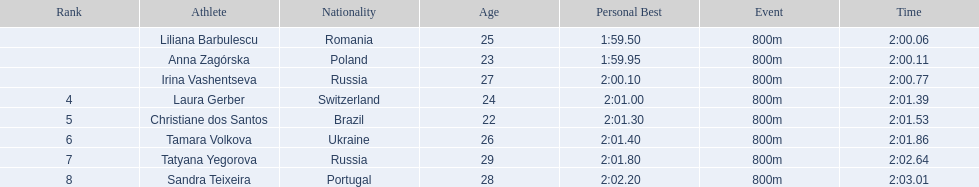What athletes are in the top five for the women's 800 metres? Liliana Barbulescu, Anna Zagórska, Irina Vashentseva, Laura Gerber, Christiane dos Santos. Which athletes are in the top 3? Liliana Barbulescu, Anna Zagórska, Irina Vashentseva. Who is the second place runner in the women's 800 metres? Anna Zagórska. What is the second place runner's time? 2:00.11. 